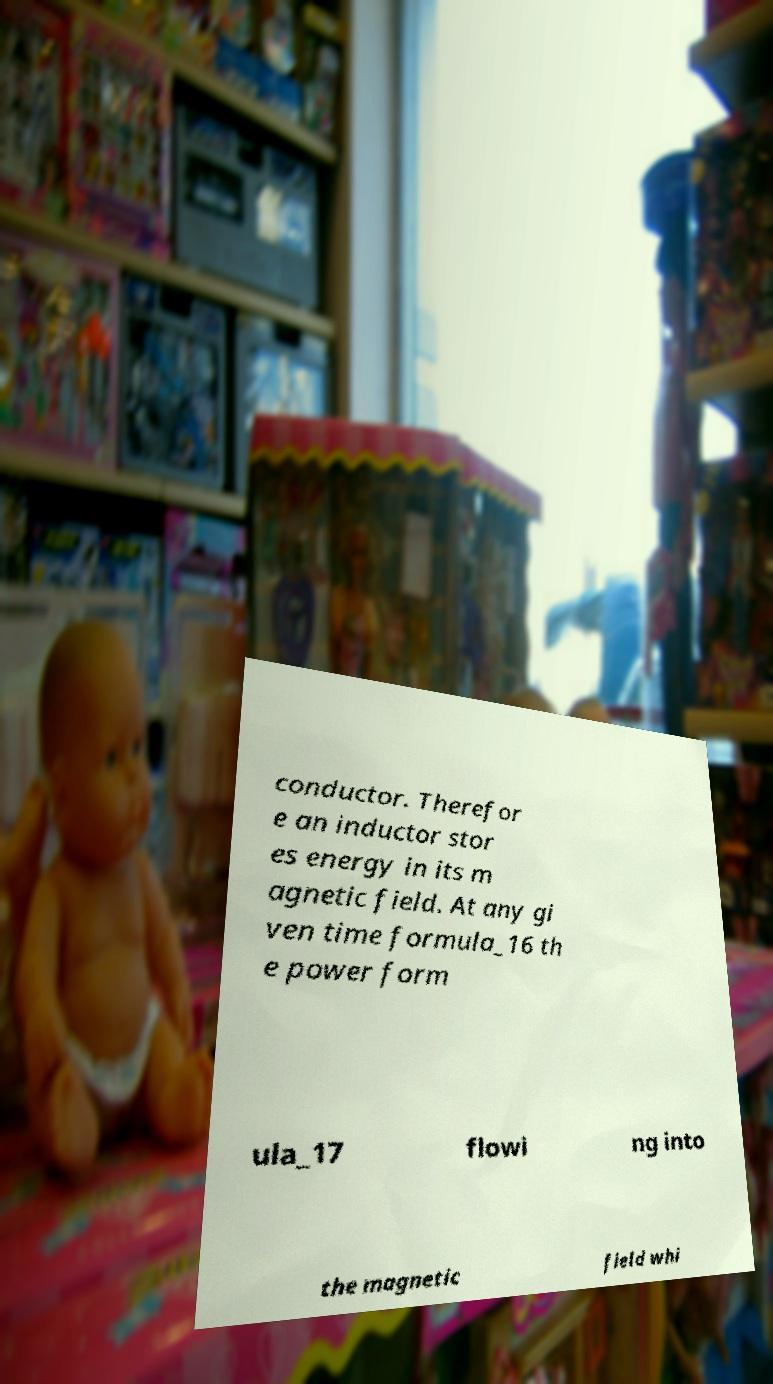For documentation purposes, I need the text within this image transcribed. Could you provide that? conductor. Therefor e an inductor stor es energy in its m agnetic field. At any gi ven time formula_16 th e power form ula_17 flowi ng into the magnetic field whi 